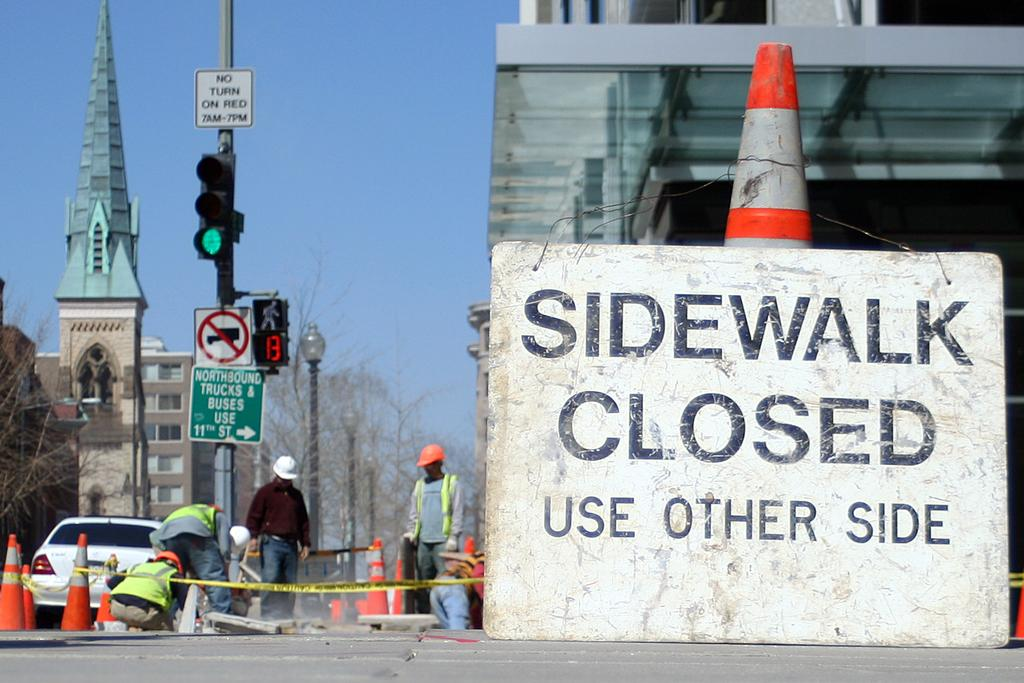Provide a one-sentence caption for the provided image. A construction zone with a huge sign stating Sidewalk closed, use other side. 